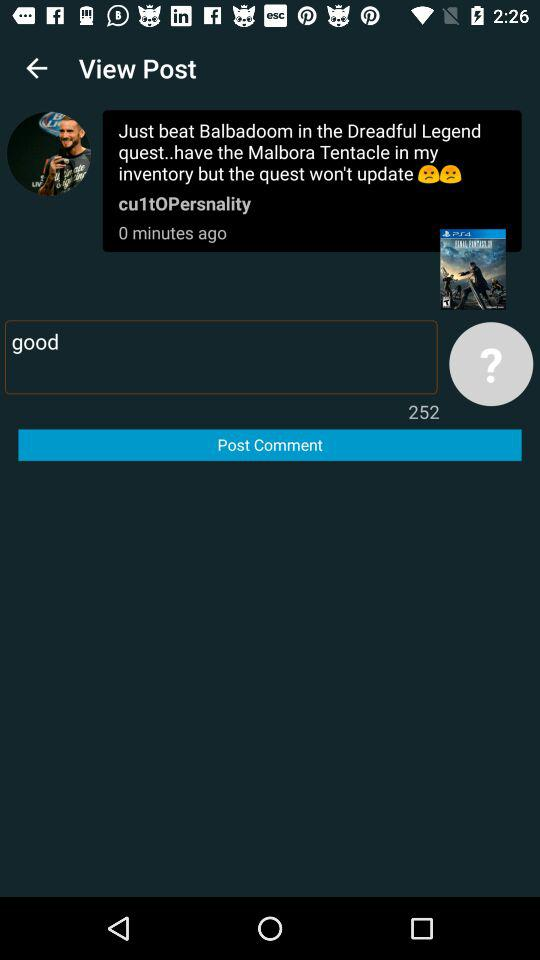What is the username who posted the comments? The username is "cu1tOPersnality". 